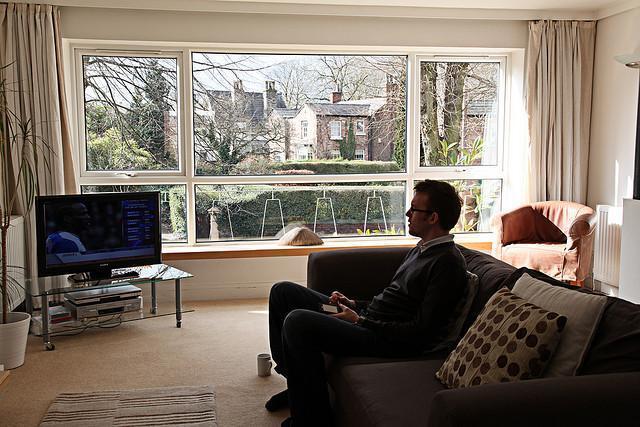How many pillows are there?
Give a very brief answer. 3. How many window panes are there?
Give a very brief answer. 6. How many couches are in the photo?
Give a very brief answer. 2. 